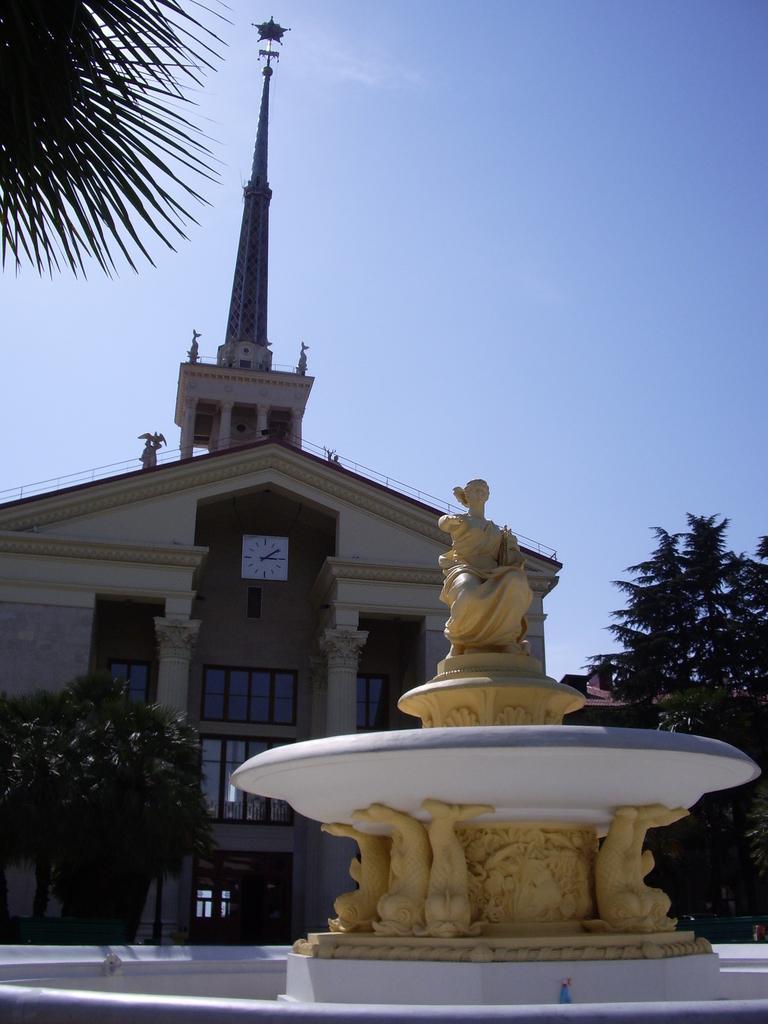Can you describe this image briefly? There is a statue on a stand. Below the stand there are some sculptures. In the back there is a building with clock, pillars, windows. On the sides there are trees. In the background there is sky. 